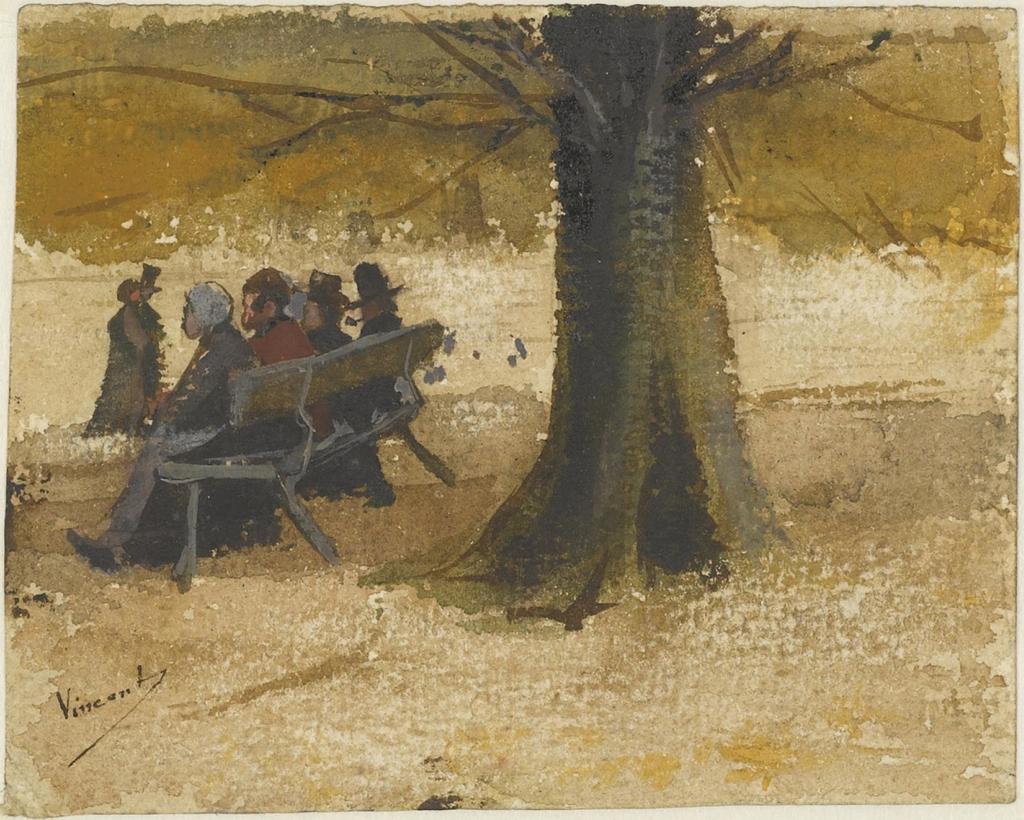How would you summarize this image in a sentence or two? This is painting,we can see these people sitting on bench and this person standing and we can see tree. 